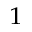Convert formula to latex. <formula><loc_0><loc_0><loc_500><loc_500>^ { 1 }</formula> 